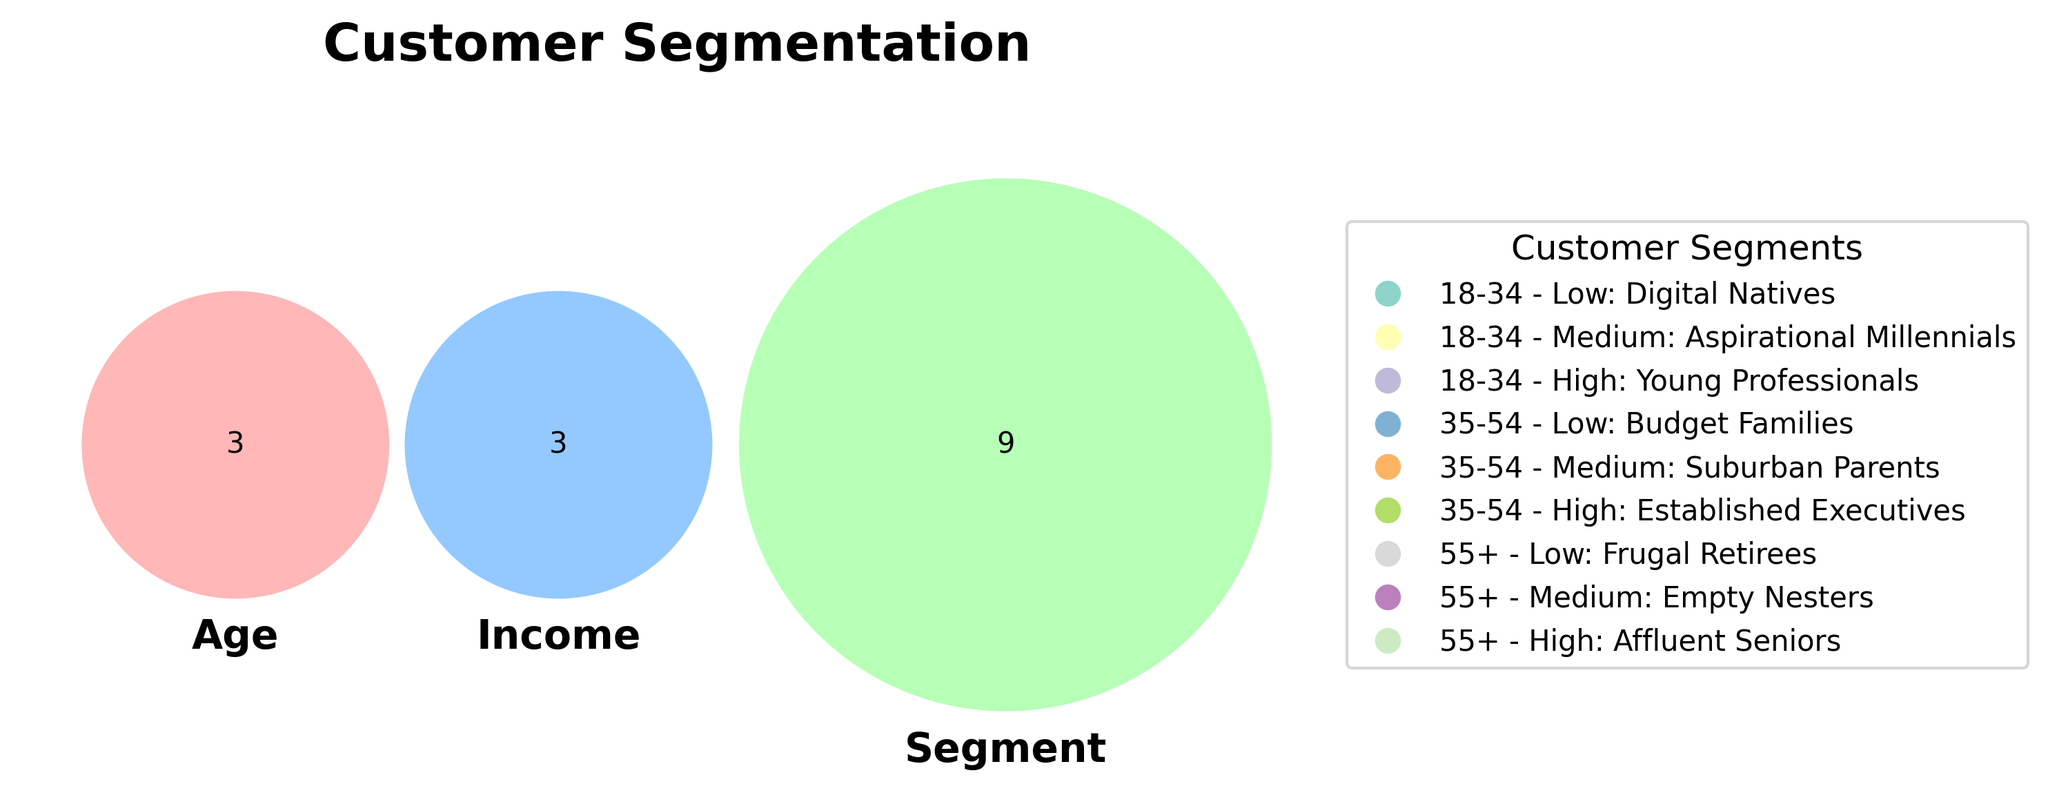Which segment is represented by the color red? The Venn diagram's legend shows that the color red corresponds to the "Low Income" segment represented by the '#FF9999' color.
Answer: Low Income How many segments are there for the 18-34 age group? The legend lists three different customer segments within the 18-34 age group: Digital Natives, Aspirational Millennials, and Young Professionals.
Answer: 3 What are the income levels represented in the Venn diagram? There are three income levels represented: Low, Medium, and High.
Answer: Low, Medium, High Are there more customer segments for age group 35-54 than for age group 55+? The legend shows three segments for age group 35-54 (Budget Families, Suburban Parents, Established Executives) and three for age group 55+ (Frugal Retirees, Empty Nesters, Affluent Seniors), so they are equal.
Answer: No Which age group has an "Affluent Seniors" segment? The legend associates "Affluent Seniors" with the 55+ age group.
Answer: 55+ How many different segments are present across all age and income combinations? Summing all segments listed in the legend, we find there are nine unique segments: Digital Natives, Aspirational Millennials, Young Professionals, Budget Families, Suburban Parents, Established Executives, Frugal Retirees, Empty Nesters, Affluent Seniors.
Answer: 9 Is there any income level that appears within all three age groups? All three income levels (Low, Medium, High) are present within all age groups (18-34, 35-54, 55+).
Answer: Yes Which segments belong to the medium income level? The legend shows that medium income level includes Aspirational Millennials, Suburban Parents, and Empty Nesters.
Answer: Aspirational Millennials, Suburban Parents, Empty Nesters Which segment has the highest-income individuals in the 35-54 age group? The legend lists Established Executives as the high-income segment for the 35-54 age group.
Answer: Established Executives 